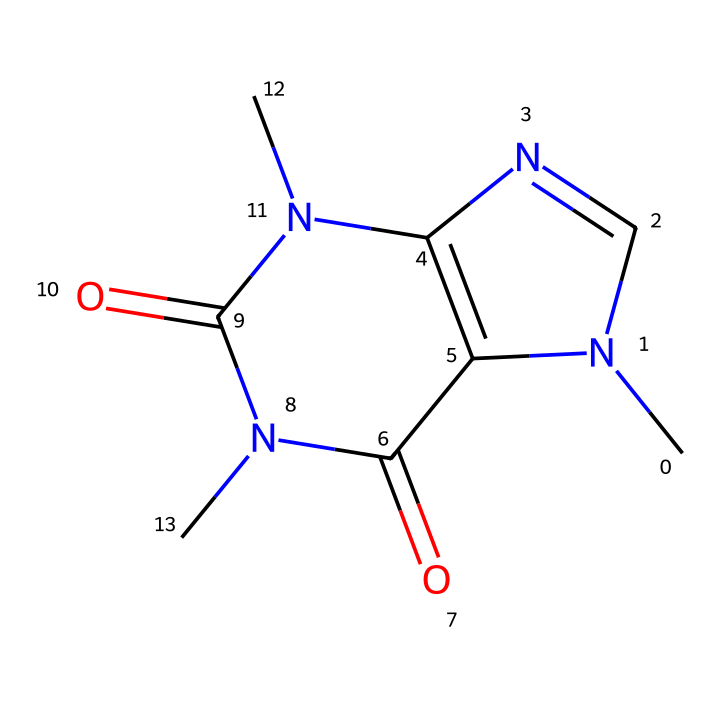What is the molecular formula of caffeine? By examining the structure, we can count the number of carbon (C), hydrogen (H), nitrogen (N), and oxygen (O) atoms present. The structure indicates there are 8 carbons, 10 hydrogens, 4 nitrogens, and 2 oxygens. Thus, the molecular formula is C8H10N4O2.
Answer: C8H10N4O2 How many nitrogen atoms are in caffeine? Looking at the structure, we can see that there are 4 nitrogen atoms present. This can be verified by counting the nitrogen atoms directly depicted in the SMILES representation.
Answer: 4 What type of structure does caffeine have? The structure depicts a bicyclic system, which is characterized by having two interconnected rings. This is identified by the presence of two fused rings in the overall structure of caffeine.
Answer: bicyclic What functional groups are present in caffeine? Analyzing the structure shows the presence of amine (–NH) groups and carbonyl (C=O) groups. The presence of nitrogen atoms indicates the presence of amine groups, while the double-bonded oxygens indicate carbonyl functional groups.
Answer: amine and carbonyl Is caffeine a type of photoreactive chemical? Caffeine can influence light reactions as it has a complex structure with regions that can react under light exposure. This can be inferred from its organic structure which may engage in photochemical reactions.
Answer: yes How many rings are in the structure of caffeine? By examining the structure closely, we note that caffeine contains two rings fused together, which can be directly counted by visual inspection of the ring structures in the formula.
Answer: 2 What is the overall charge of caffeine? The structure of caffeine is neutral because it doesn’t have any charged atoms or groups, making it overall uncharged. This can be confirmed by checking the oxidation states of all atoms in the structure.
Answer: neutral 